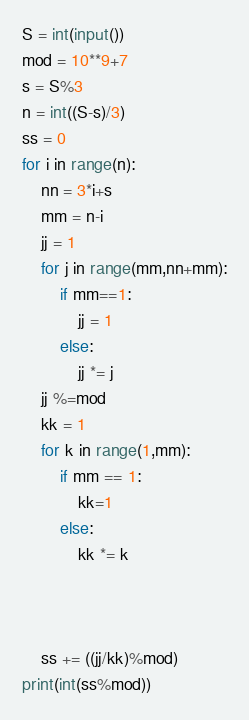Convert code to text. <code><loc_0><loc_0><loc_500><loc_500><_Python_>S = int(input())
mod = 10**9+7
s = S%3
n = int((S-s)/3)
ss = 0
for i in range(n):
    nn = 3*i+s
    mm = n-i
    jj = 1
    for j in range(mm,nn+mm):
        if mm==1:
            jj = 1
        else:
            jj *= j
    jj %=mod
    kk = 1
    for k in range(1,mm):
        if mm == 1:
            kk=1
        else:
            kk *= k
            
        
    
    ss += ((jj/kk)%mod)
print(int(ss%mod))</code> 